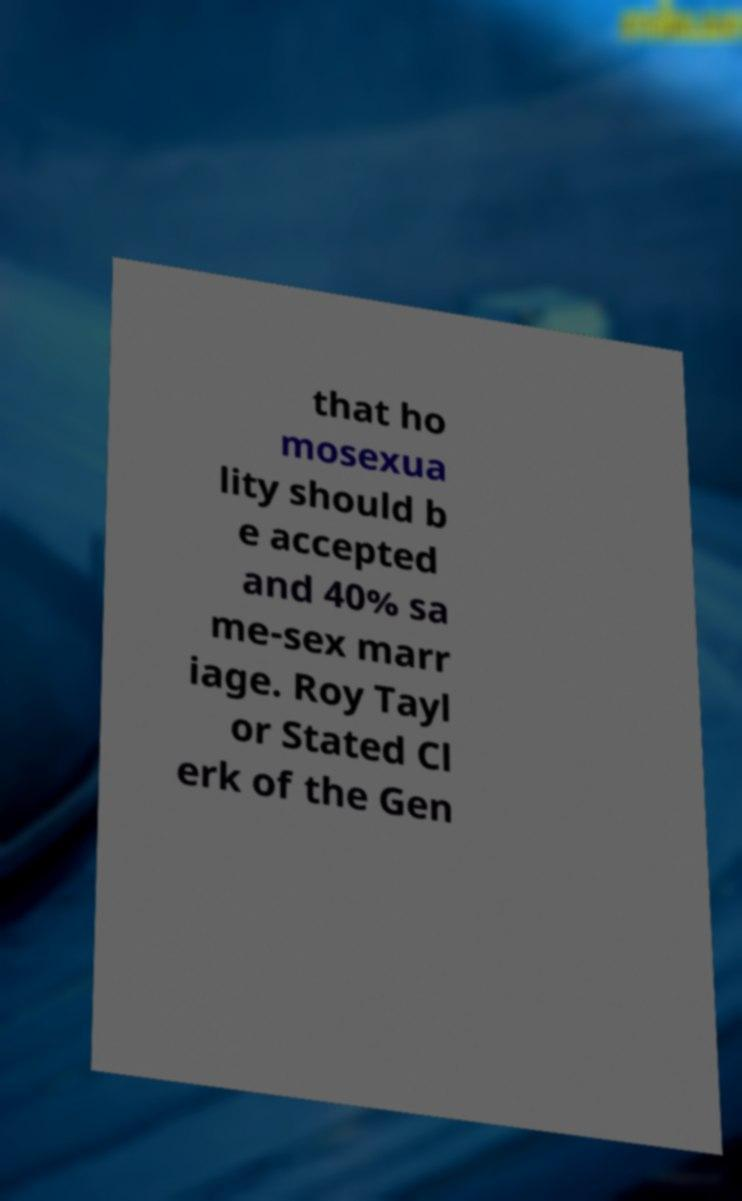What messages or text are displayed in this image? I need them in a readable, typed format. that ho mosexua lity should b e accepted and 40% sa me-sex marr iage. Roy Tayl or Stated Cl erk of the Gen 